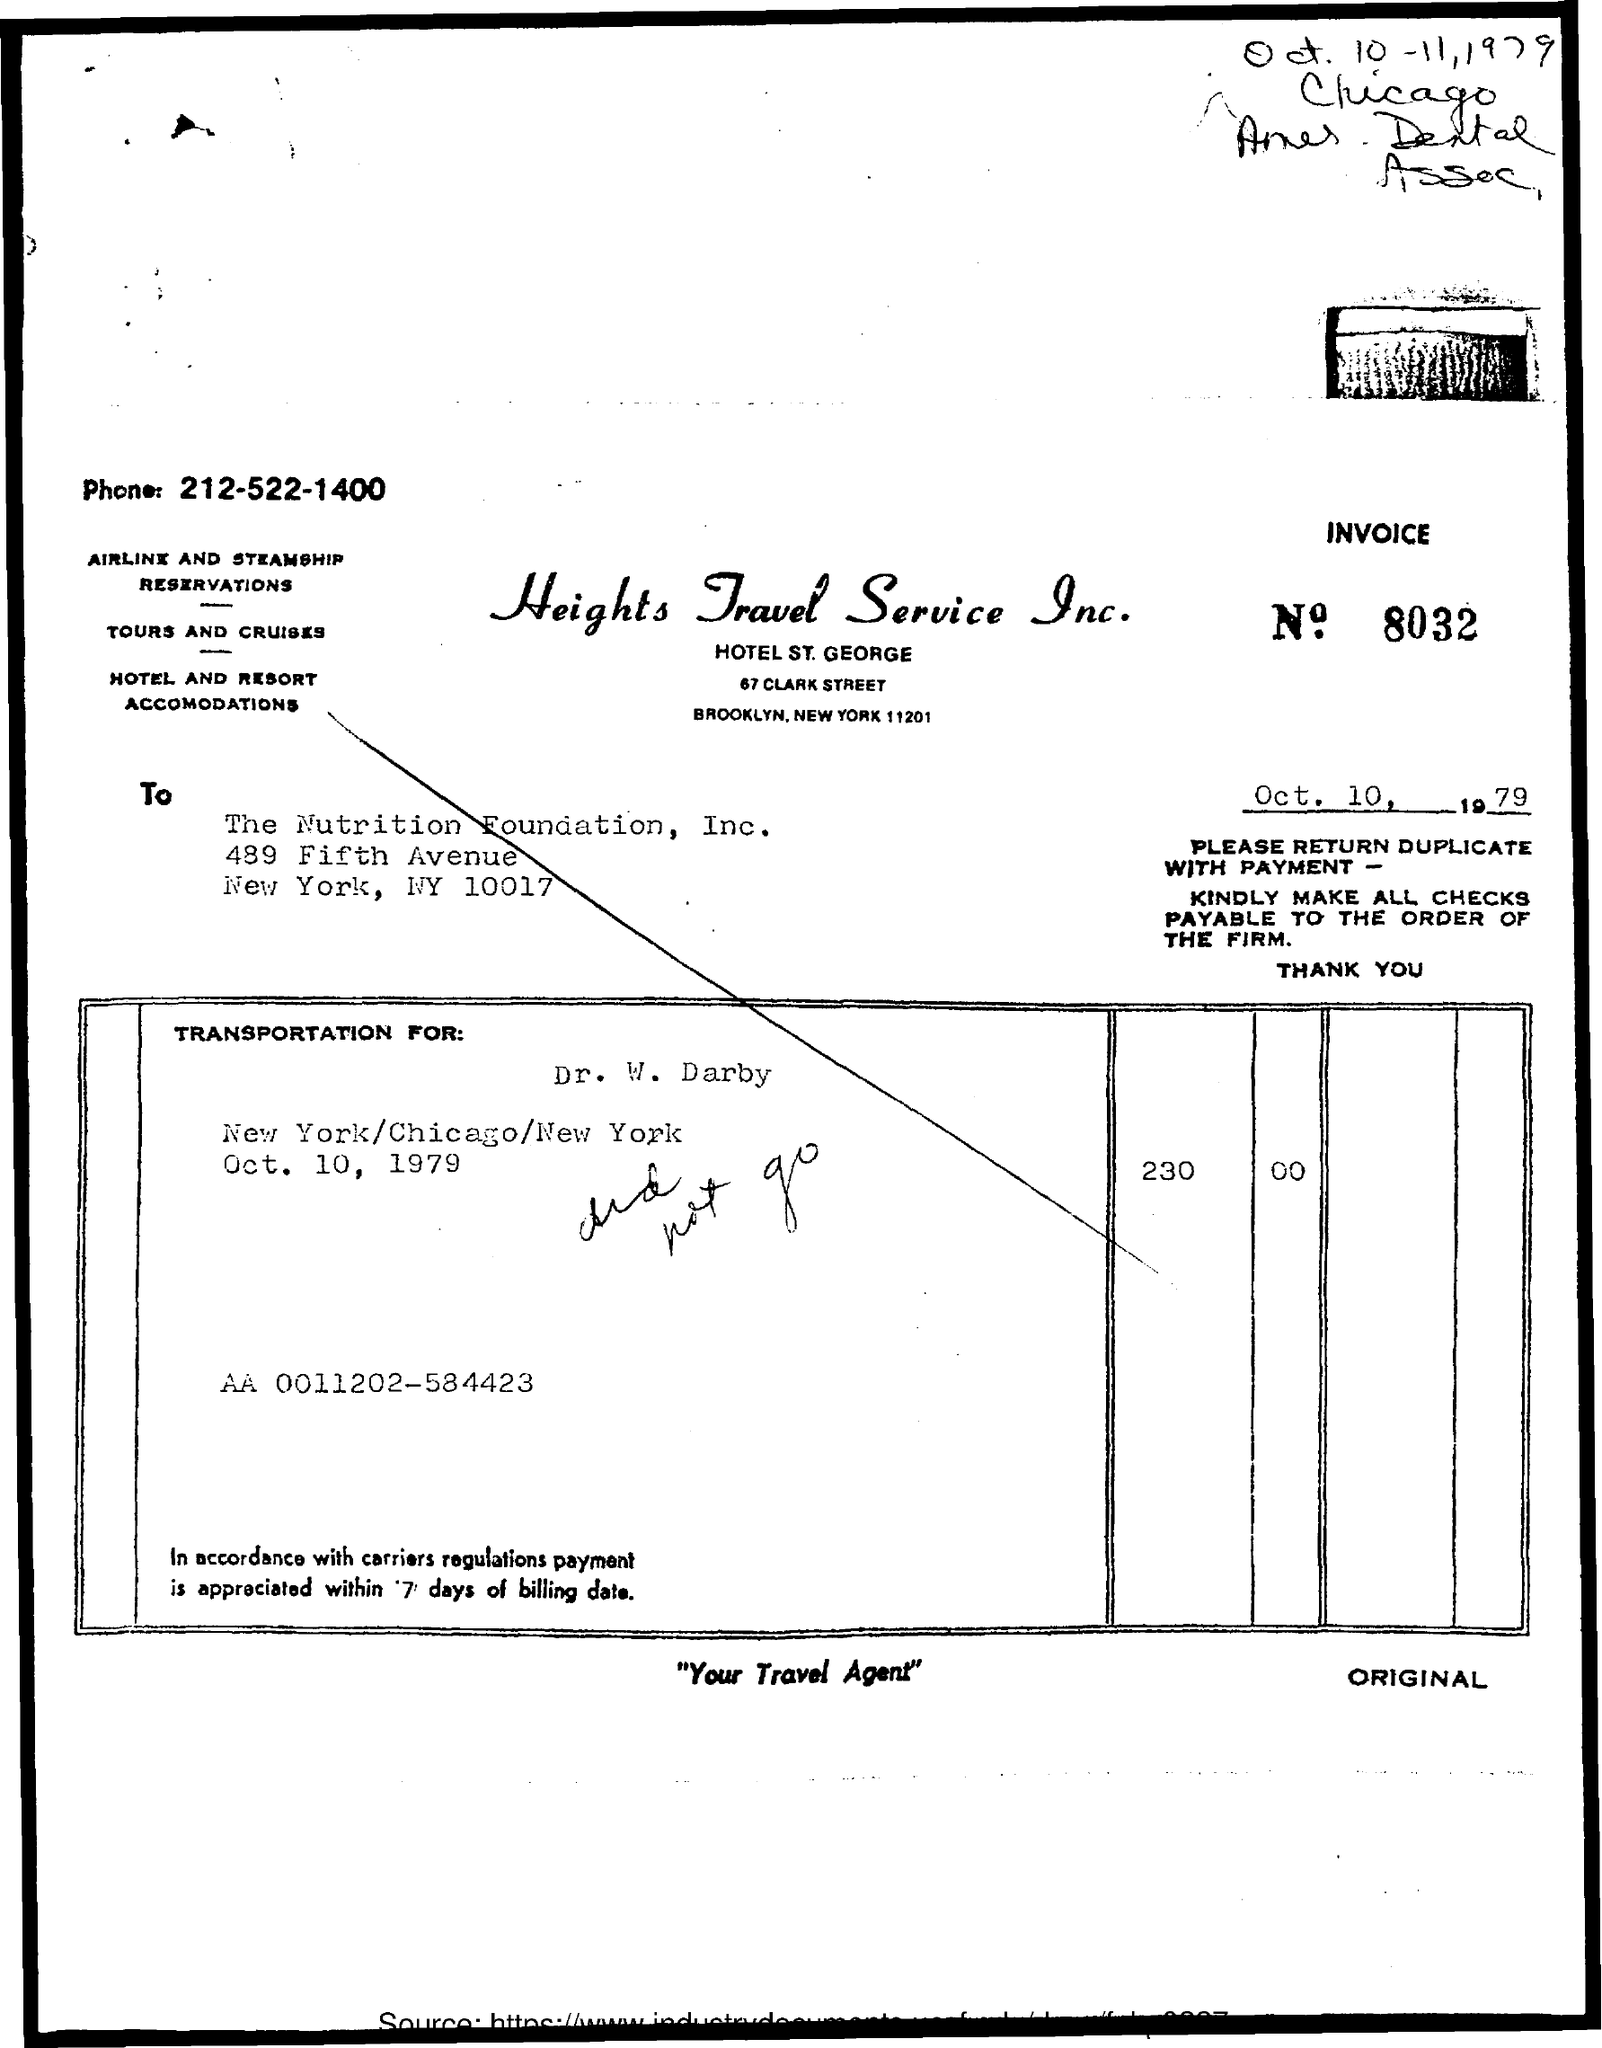Draw attention to some important aspects in this diagram. Heights Travel Service Inc. can be contacted by phone at 212-522-1400. The invoice number provided in the document is 8032. The invoice is issued by The Nutrition Foundation, Inc. in [company name]. The invoice was issued by Heights Travel Service Inc. The issued date of the invoice is October 10th, 1979. 